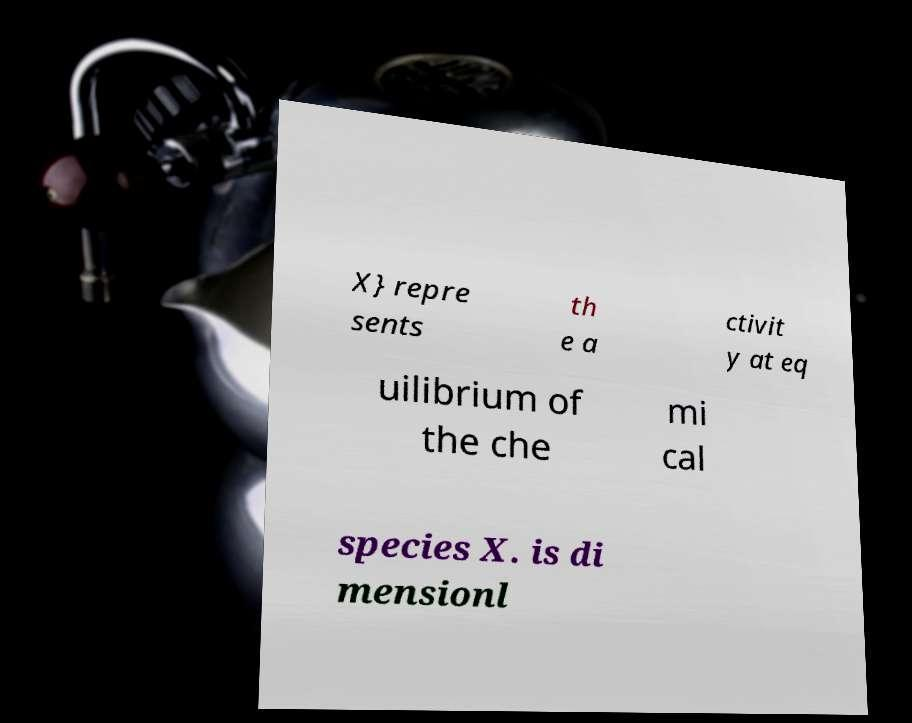I need the written content from this picture converted into text. Can you do that? X} repre sents th e a ctivit y at eq uilibrium of the che mi cal species X. is di mensionl 